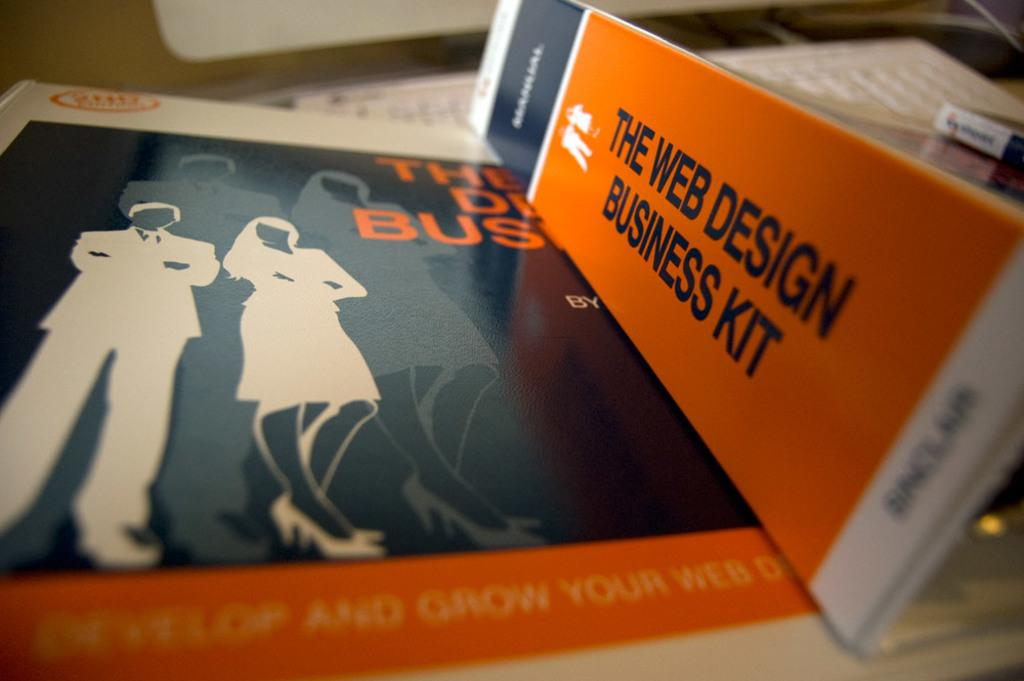<image>
Describe the image concisely. A couple of Web Design Business Kit binders are laying on a desk. 